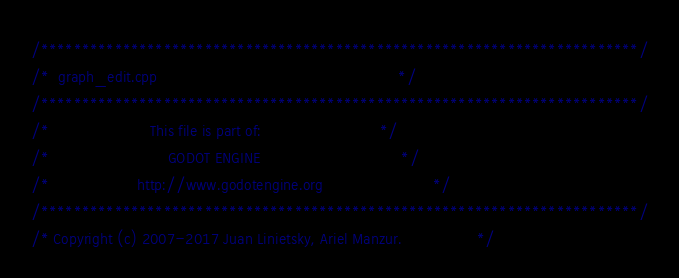Convert code to text. <code><loc_0><loc_0><loc_500><loc_500><_C++_>/*************************************************************************/
/*  graph_edit.cpp                                                       */
/*************************************************************************/
/*                       This file is part of:                           */
/*                           GODOT ENGINE                                */
/*                    http://www.godotengine.org                         */
/*************************************************************************/
/* Copyright (c) 2007-2017 Juan Linietsky, Ariel Manzur.                 */</code> 